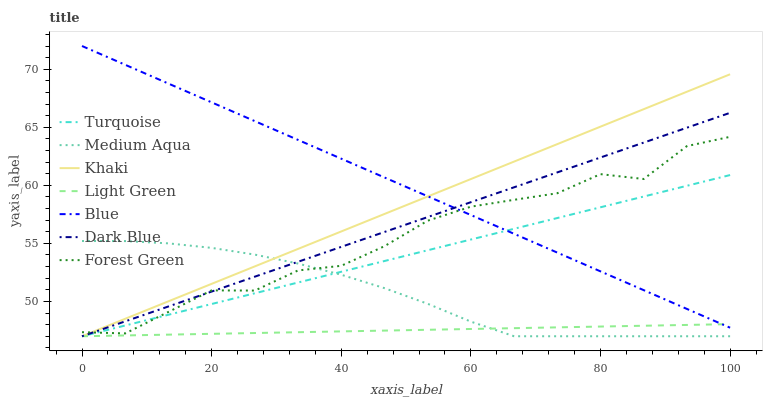Does Light Green have the minimum area under the curve?
Answer yes or no. Yes. Does Blue have the maximum area under the curve?
Answer yes or no. Yes. Does Turquoise have the minimum area under the curve?
Answer yes or no. No. Does Turquoise have the maximum area under the curve?
Answer yes or no. No. Is Turquoise the smoothest?
Answer yes or no. Yes. Is Forest Green the roughest?
Answer yes or no. Yes. Is Khaki the smoothest?
Answer yes or no. No. Is Khaki the roughest?
Answer yes or no. No. Does Turquoise have the lowest value?
Answer yes or no. Yes. Does Forest Green have the lowest value?
Answer yes or no. No. Does Blue have the highest value?
Answer yes or no. Yes. Does Turquoise have the highest value?
Answer yes or no. No. Is Medium Aqua less than Blue?
Answer yes or no. Yes. Is Forest Green greater than Light Green?
Answer yes or no. Yes. Does Dark Blue intersect Khaki?
Answer yes or no. Yes. Is Dark Blue less than Khaki?
Answer yes or no. No. Is Dark Blue greater than Khaki?
Answer yes or no. No. Does Medium Aqua intersect Blue?
Answer yes or no. No. 